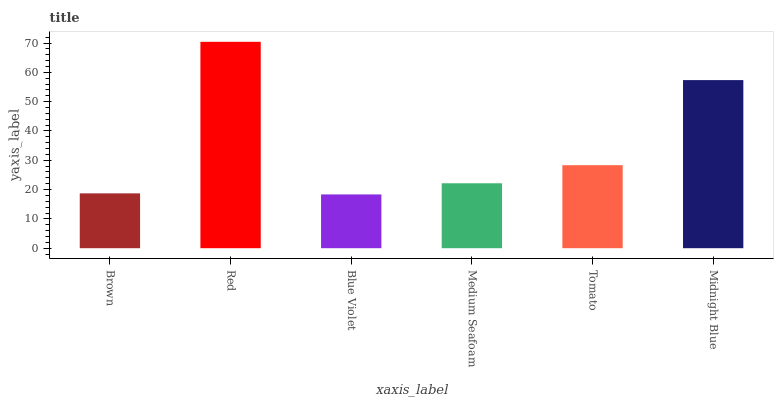Is Blue Violet the minimum?
Answer yes or no. Yes. Is Red the maximum?
Answer yes or no. Yes. Is Red the minimum?
Answer yes or no. No. Is Blue Violet the maximum?
Answer yes or no. No. Is Red greater than Blue Violet?
Answer yes or no. Yes. Is Blue Violet less than Red?
Answer yes or no. Yes. Is Blue Violet greater than Red?
Answer yes or no. No. Is Red less than Blue Violet?
Answer yes or no. No. Is Tomato the high median?
Answer yes or no. Yes. Is Medium Seafoam the low median?
Answer yes or no. Yes. Is Brown the high median?
Answer yes or no. No. Is Blue Violet the low median?
Answer yes or no. No. 